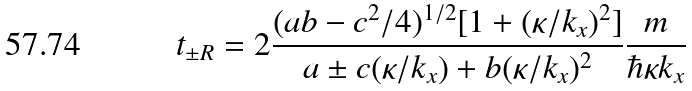<formula> <loc_0><loc_0><loc_500><loc_500>t _ { \pm R } = 2 \frac { ( a b - c ^ { 2 } / 4 ) ^ { 1 / 2 } [ 1 + ( \kappa / k _ { x } ) ^ { 2 } ] } { a \pm c ( \kappa / k _ { x } ) + b ( \kappa / k _ { x } ) ^ { 2 } } \frac { m } { \hbar { \kappa } k _ { x } }</formula> 